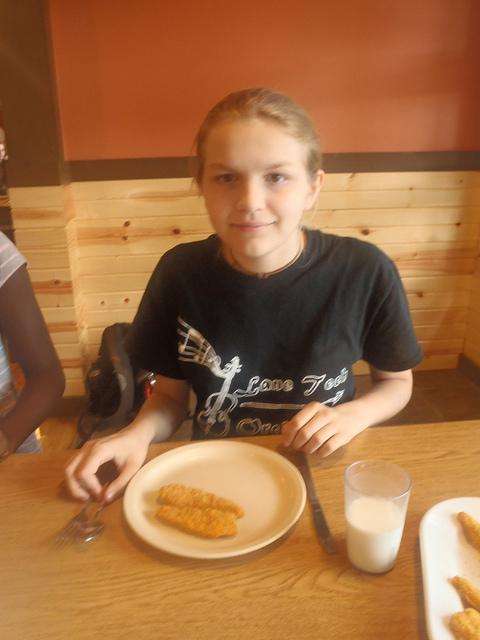What is she drinking?
Keep it brief. Milk. What kind of food is this?
Concise answer only. Chicken. Is this girls plate full?
Be succinct. No. 